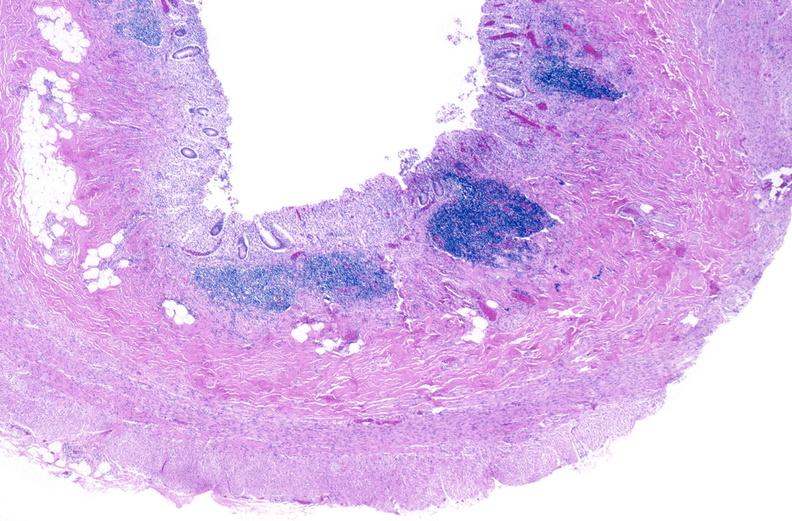does this image show normal appendix?
Answer the question using a single word or phrase. Yes 